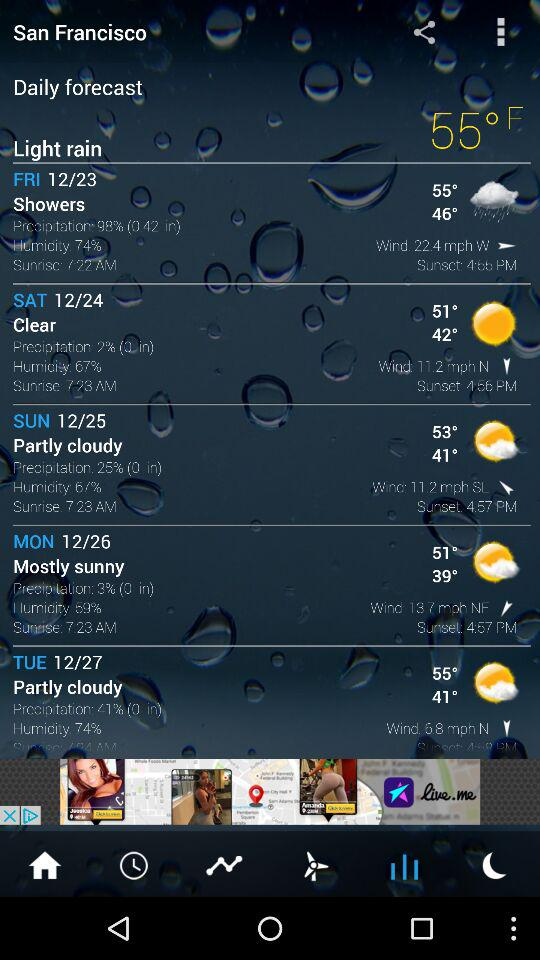What is the temperature on Monday? The temperature on Monday is 51 degree. 